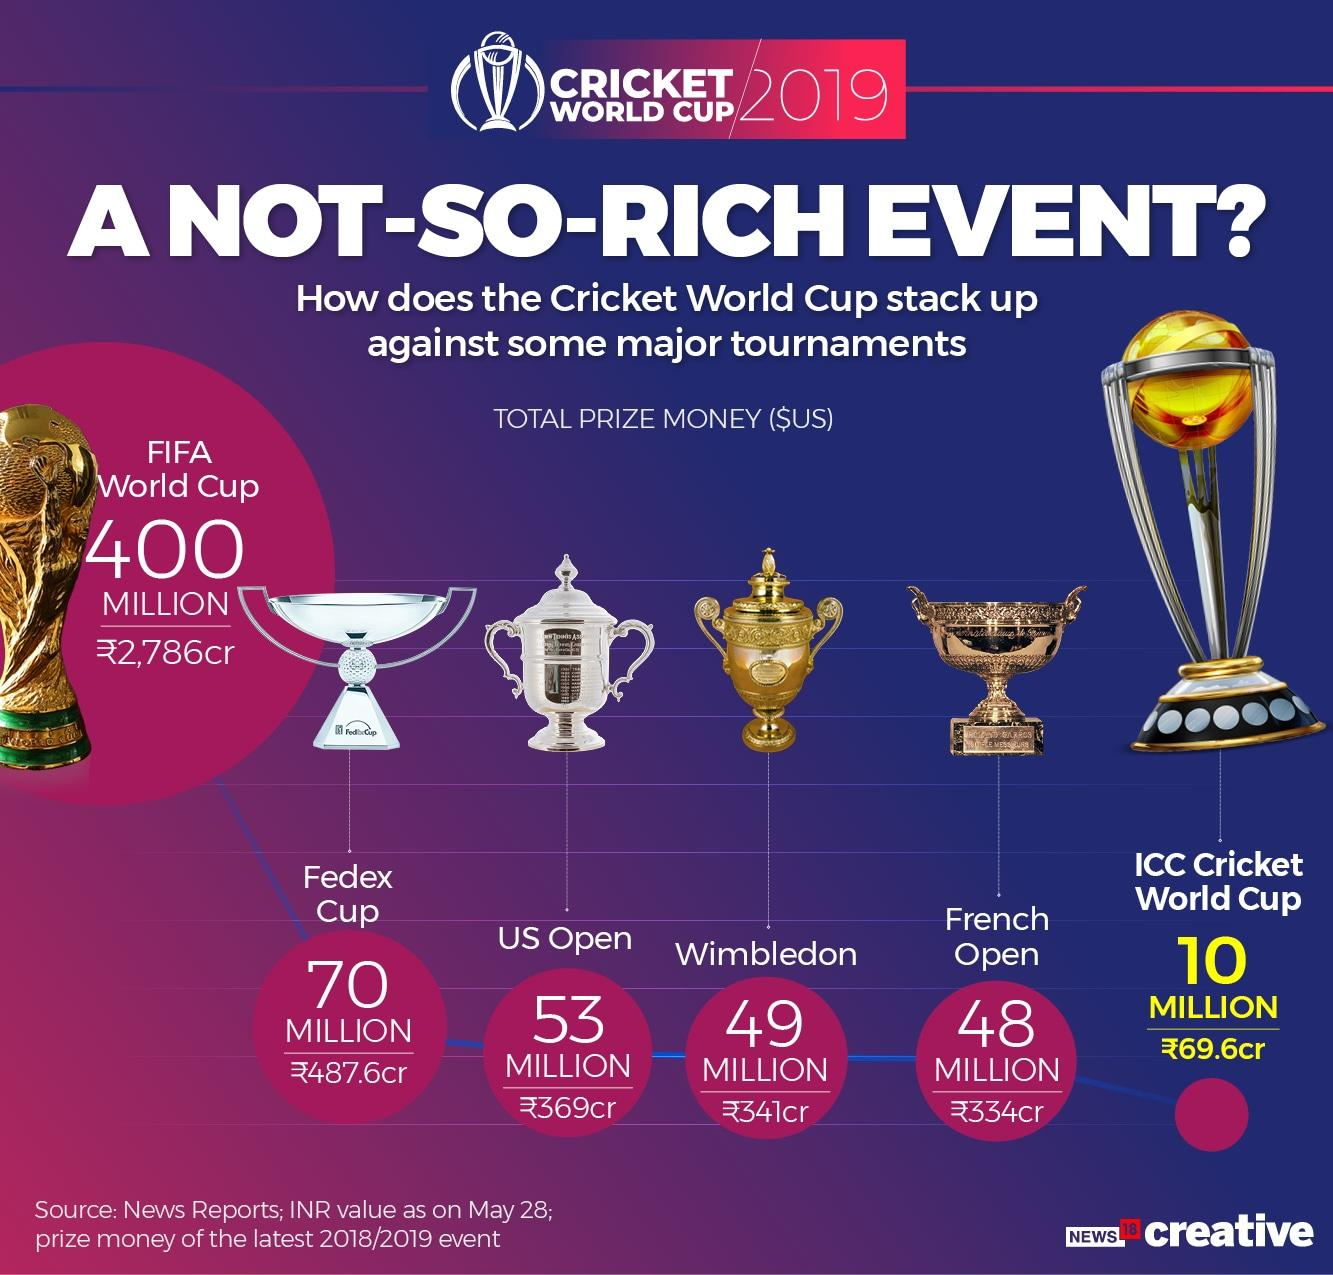Draw attention to some important aspects in this diagram. The infographic mentions three major tennis tournaments. The US Open is the tennis tournament that offers the highest prize money among all Grand Slam events. The color of the Wimbledon trophy is gold. The total prize money allotted for the US Open is $53 million. Wimbledon, one of the most prestigious tennis tournaments in the world, offers a total prize money of 49 million US dollars. 